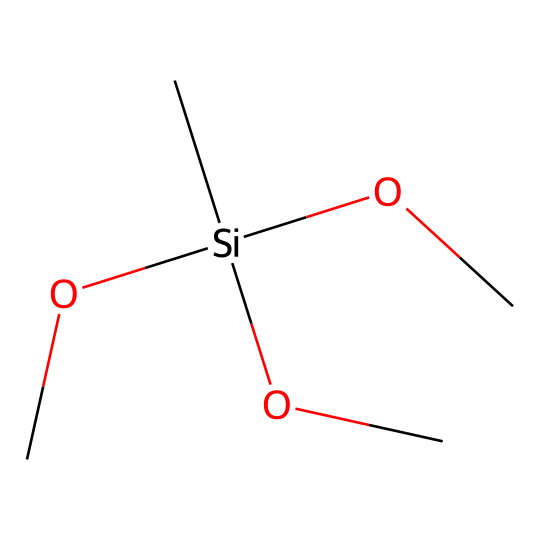What type of chemical is represented by this SMILES? The given SMILES corresponds to a silane compound as it contains silicon (Si) connected to organic groups (in this case, methyl and alkoxy groups). Silanes are classified as organosilicon compounds.
Answer: silane How many oxygen atoms are present in this compound? By examining the SMILES notation, we see "OC" repeated three times, indicating three oxygen atoms. Each "OC" group signifies one oxygen atom bonded to carbon.
Answer: three What is the degree of branching in this compound? The structure shows a silicon atom bonded to three separate alkoxy groups and one carbon atom, indicating it is highly branched at the silicon center. There are no linear chains.
Answer: high What is the functional group present in this organosilicon compound? The presence of the "OC" segments indicates that the functional groups are alkoxy groups (in this case, methoxy). The reactivity is influenced by these groups' structure.
Answer: alkoxy What is the total number of carbon atoms in the compound? The compound features three methoxy groups (C) and one central carbon atom attached to silicon. Therefore, the total number of carbon atoms is four.
Answer: four 